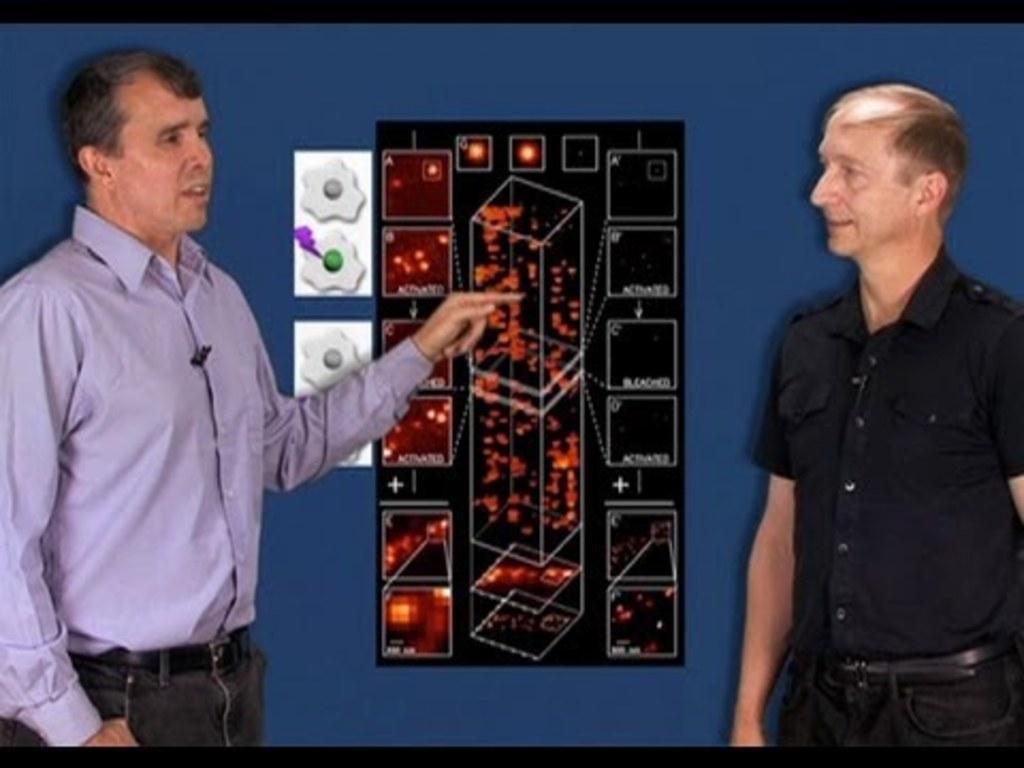How would you summarize this image in a sentence or two? This picture seems to be clicked inside the room and we can see the two men wearing shirts and standing. In the background there is a blue color object which seems to be the digital screen and we can see the text and some pictures on the screen. 